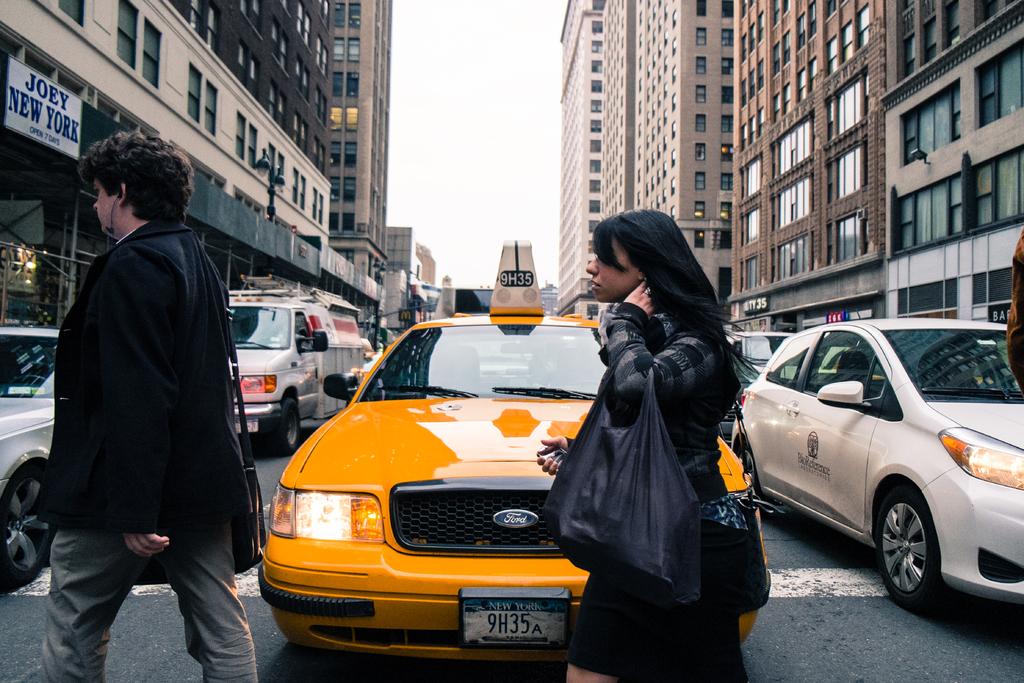What state is the license plate?
Offer a terse response. New york. What is the license plate number?
Offer a very short reply. 9h35a. 